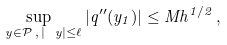Convert formula to latex. <formula><loc_0><loc_0><loc_500><loc_500>\sup _ { \ y \in \mathcal { P } \, , \, | \ y | \leq \ell } | q ^ { \prime \prime } ( y _ { 1 } ) | \leq M h ^ { 1 / 2 } \, ,</formula> 